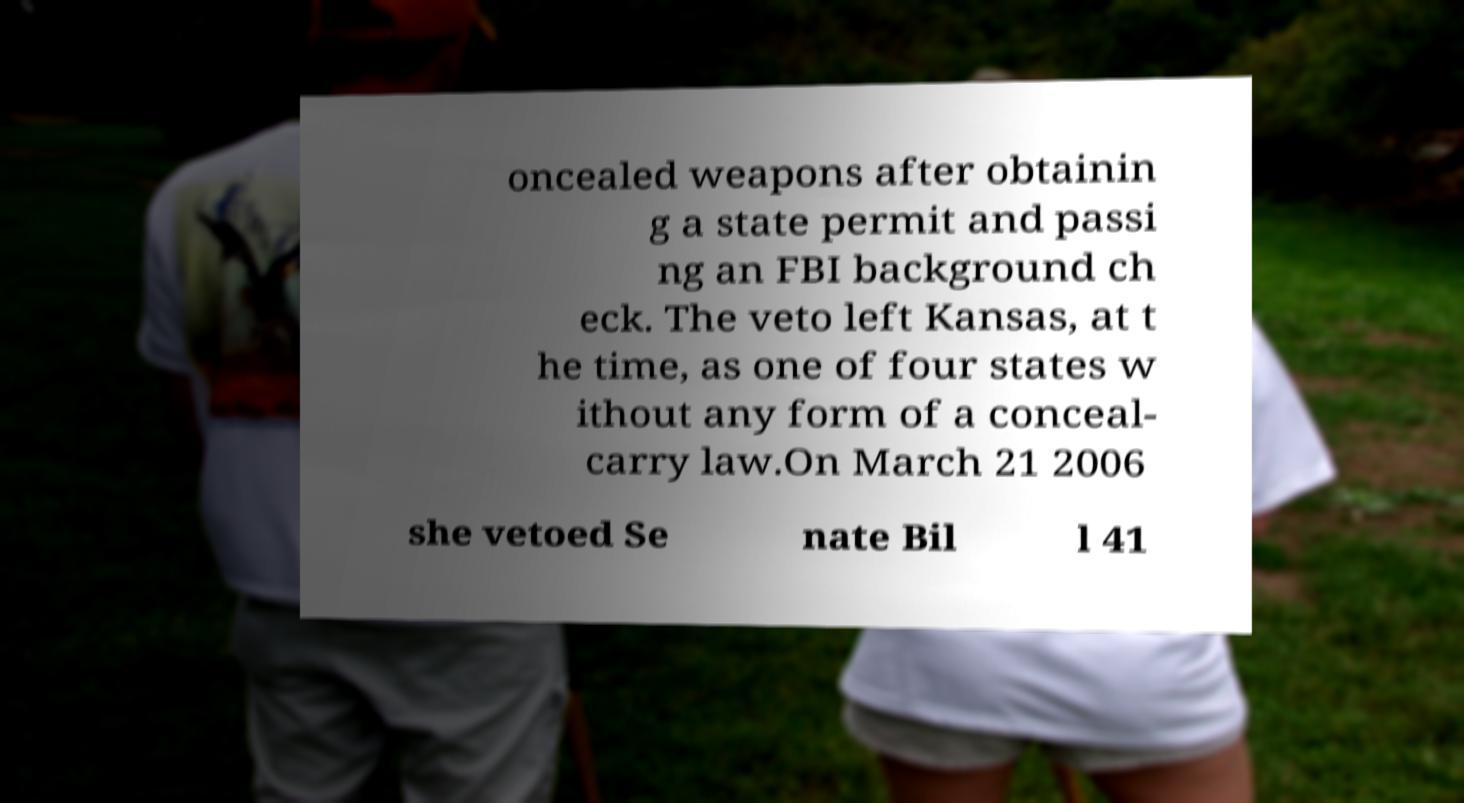Can you accurately transcribe the text from the provided image for me? oncealed weapons after obtainin g a state permit and passi ng an FBI background ch eck. The veto left Kansas, at t he time, as one of four states w ithout any form of a conceal- carry law.On March 21 2006 she vetoed Se nate Bil l 41 